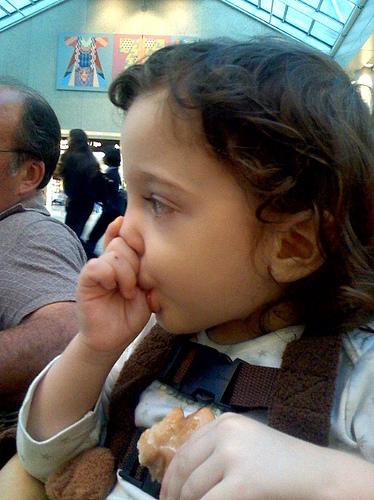Is this a boy or a girl?
Be succinct. Girl. What is in the child's mouth?
Answer briefly. Thumb. What is the child harnessed to?
Keep it brief. Chair. 